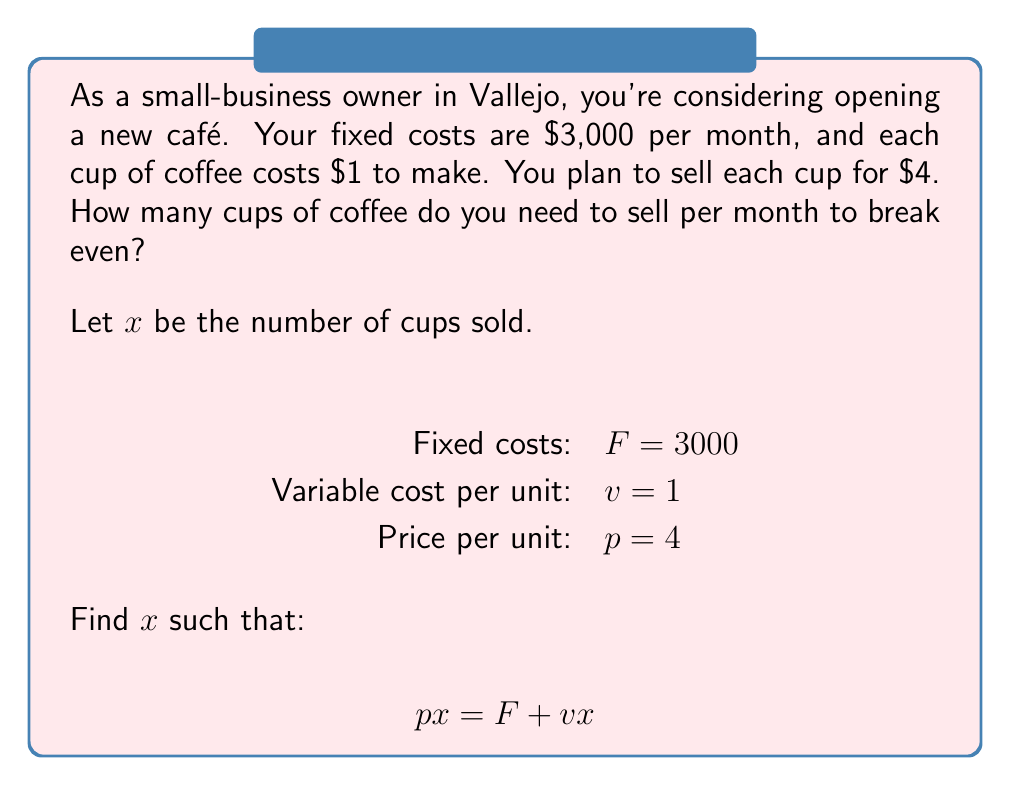Can you solve this math problem? To find the break-even point, we need to find the number of units (cups of coffee) where total revenue equals total costs.

1) Set up the equation:
   Total Revenue = Total Costs
   $px = F + vx$

2) Substitute the known values:
   $4x = 3000 + 1x$

3) Simplify by subtracting $1x$ from both sides:
   $3x = 3000$

4) Divide both sides by 3:
   $x = 1000$

Therefore, you need to sell 1000 cups of coffee per month to break even.

To verify:
- Revenue: $1000 \times $4 = $4000$
- Costs: $3000 + (1000 \times $1) = $4000$

Revenue equals costs, confirming the break-even point.
Answer: 1000 cups 